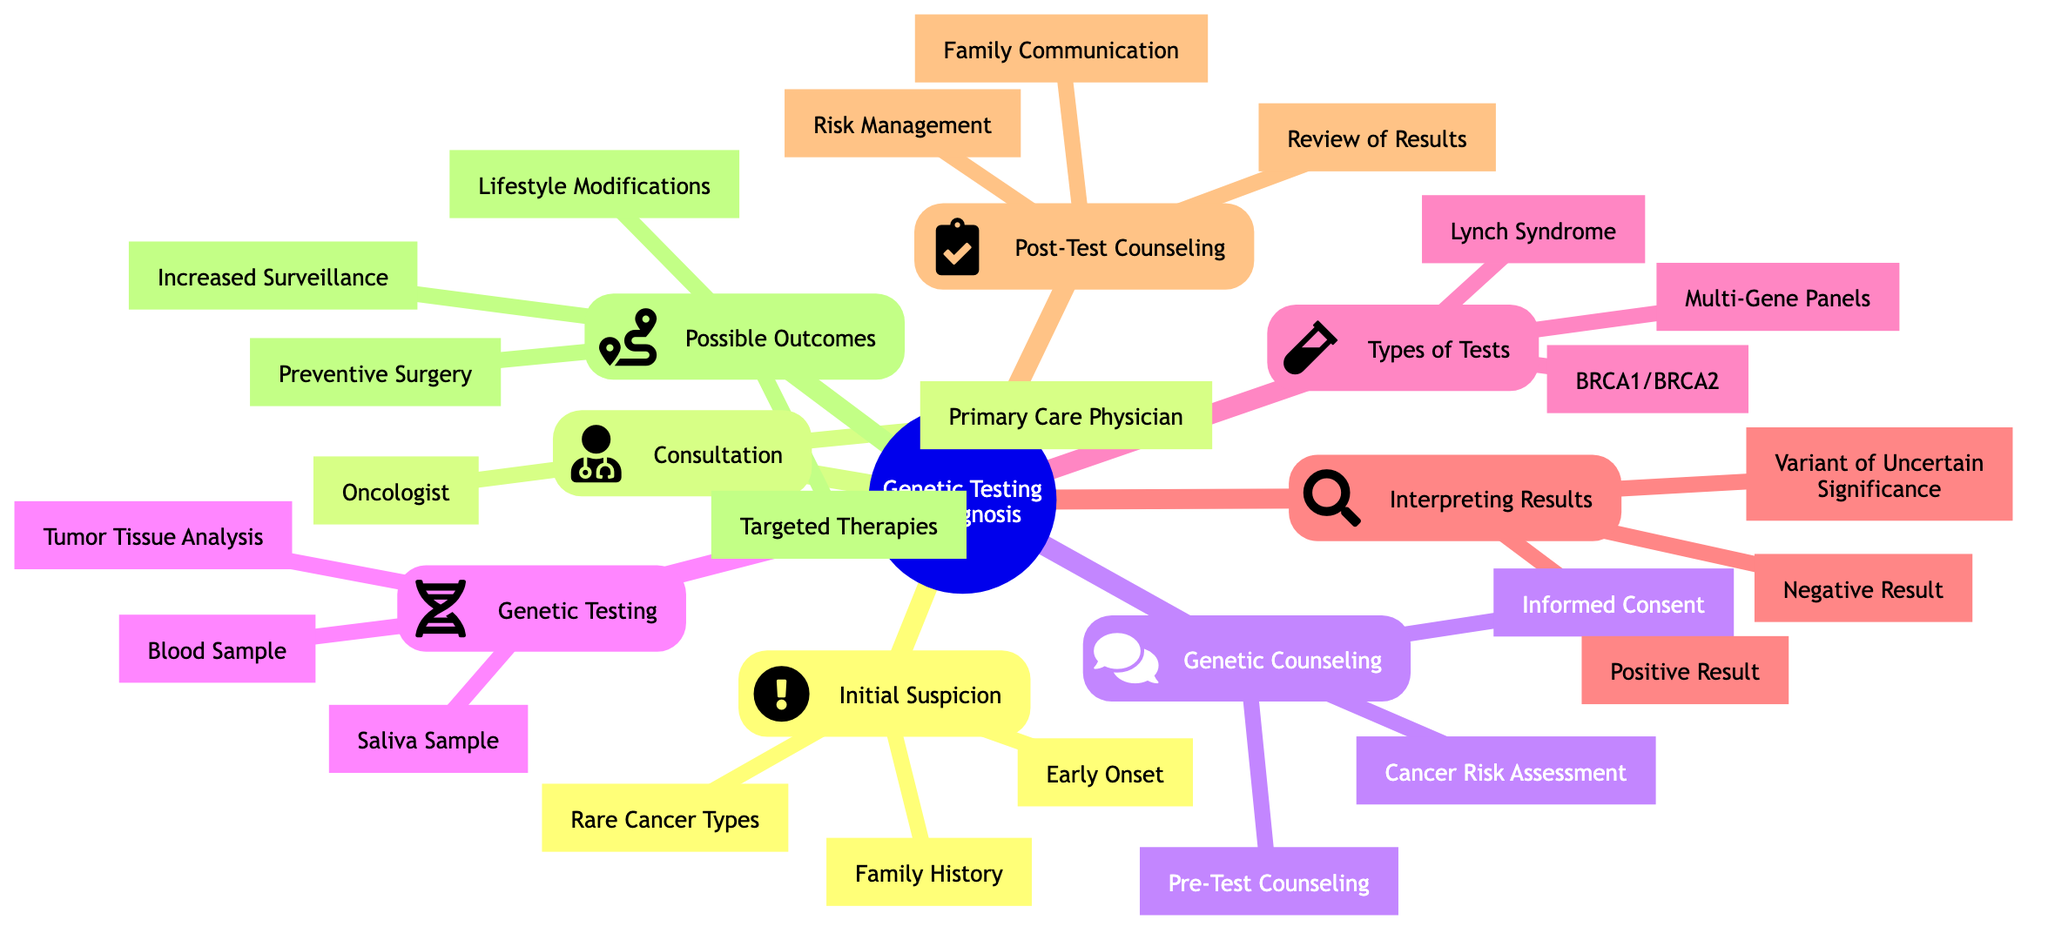What are the three initial suspicion indicators? The diagram lists "Family History," "Early Onset," and "Rare Cancer Types" as indicators of initial suspicion.
Answer: Family History, Early Onset, Rare Cancer Types Who do you consult after initial suspicion? After initial suspicion, the diagram suggests consulting a "Primary Care Physician" and an "Oncologist."
Answer: Primary Care Physician, Oncologist How many types of genetic tests are mentioned? The diagram includes three types of tests: "BRCA1/BRCA2," "Lynch Syndrome," and "Multi-Gene Panels."
Answer: 3 What happens in the case of a positive result? According to the diagram, a positive result indicates "Identifies a pathogenic mutation, confirming increased cancer risk."
Answer: Identifies a pathogenic mutation, confirming increased cancer risk What is the goal of post-test counseling? The diagram states that the goal of post-test counseling is to "Discuss the meaning of test results and next steps."
Answer: Discuss the meaning of test results and next steps What do variant results indicate? The diagram describes a "Variant of Uncertain Significance (VUS)" as findings with unclear implications that require further study.
Answer: Findings with unclear implications If someone tests positive, what is one possible outcome? The diagram indicates that one possible outcome of a positive test result is "Increased Surveillance."
Answer: Increased Surveillance How does genetic counseling interact with genetic testing? The diagram shows that genetic counseling includes pre-test discussions and risk assessments that lead to informed consent for genetic testing.
Answer: Includes pre-test discussions and risk assessments What technique is suggested as a non-invasive alternative for genetic testing? The diagram lists "Saliva Sample Collection" as a non-invasive alternative to blood sample collection for genetic testing.
Answer: Saliva Sample Collection 